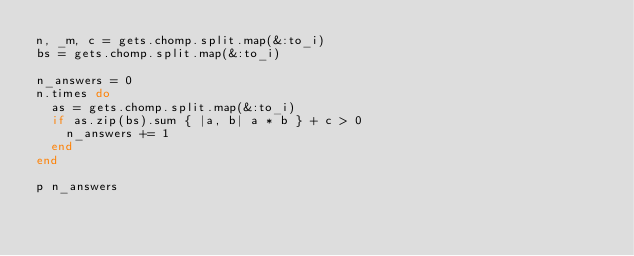Convert code to text. <code><loc_0><loc_0><loc_500><loc_500><_Ruby_>n, _m, c = gets.chomp.split.map(&:to_i)
bs = gets.chomp.split.map(&:to_i)

n_answers = 0
n.times do
  as = gets.chomp.split.map(&:to_i)
  if as.zip(bs).sum { |a, b| a * b } + c > 0
    n_answers += 1
  end
end

p n_answers
</code> 